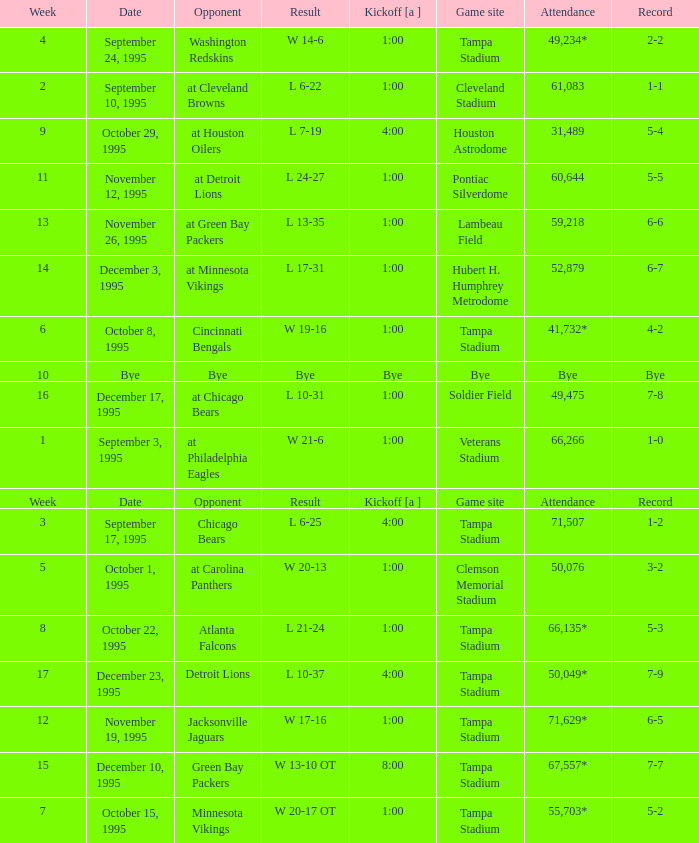Who did the Tampa Bay Buccaneers play on december 23, 1995? Detroit Lions. 